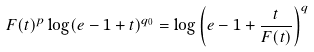Convert formula to latex. <formula><loc_0><loc_0><loc_500><loc_500>F ( t ) ^ { p } \log ( e - 1 + t ) ^ { q _ { 0 } } = \log \left ( e - 1 + \frac { t } { F ( t ) } \right ) ^ { q }</formula> 